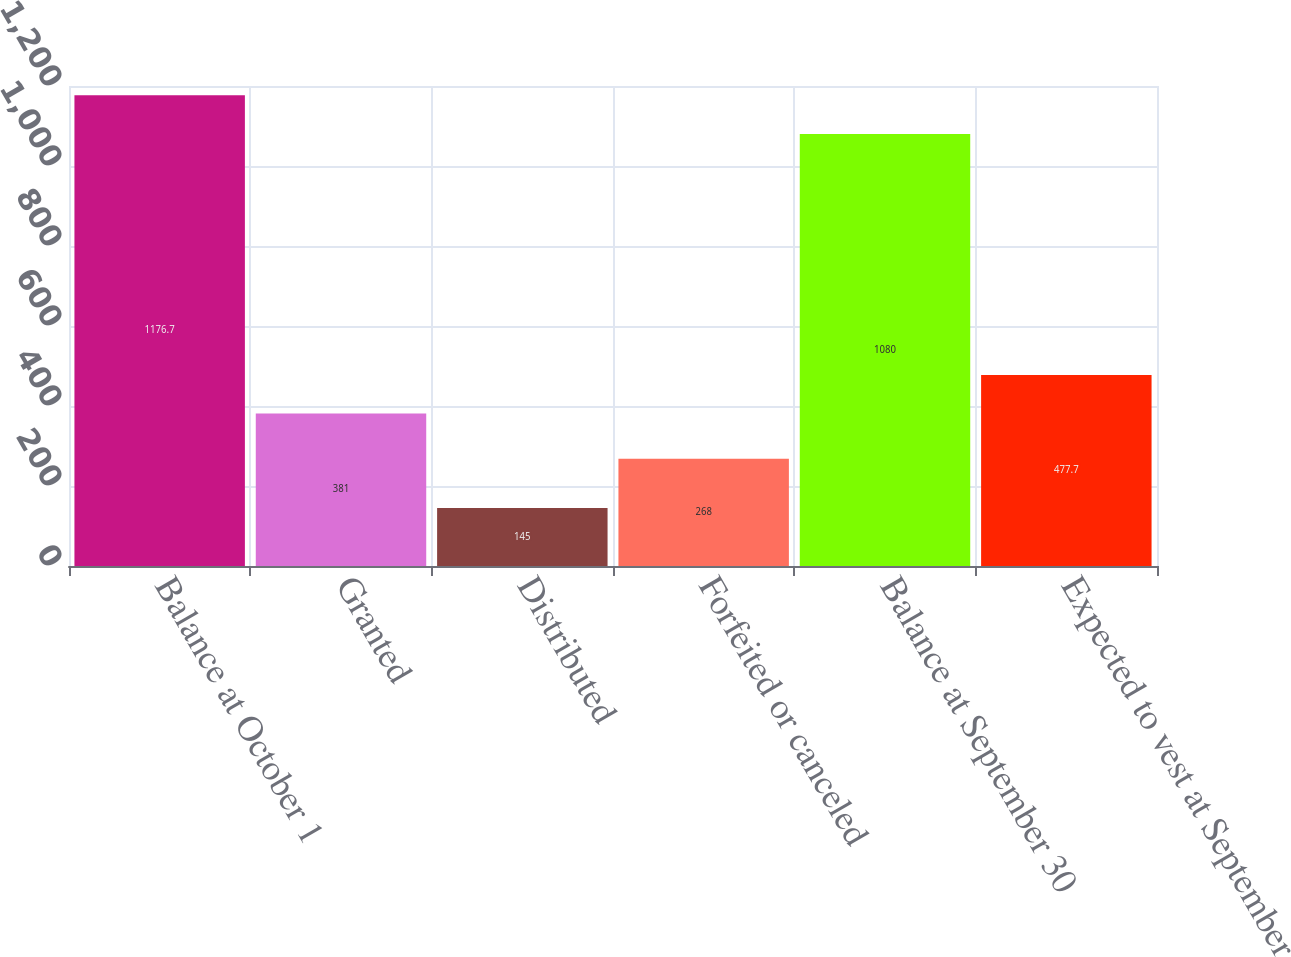<chart> <loc_0><loc_0><loc_500><loc_500><bar_chart><fcel>Balance at October 1<fcel>Granted<fcel>Distributed<fcel>Forfeited or canceled<fcel>Balance at September 30<fcel>Expected to vest at September<nl><fcel>1176.7<fcel>381<fcel>145<fcel>268<fcel>1080<fcel>477.7<nl></chart> 